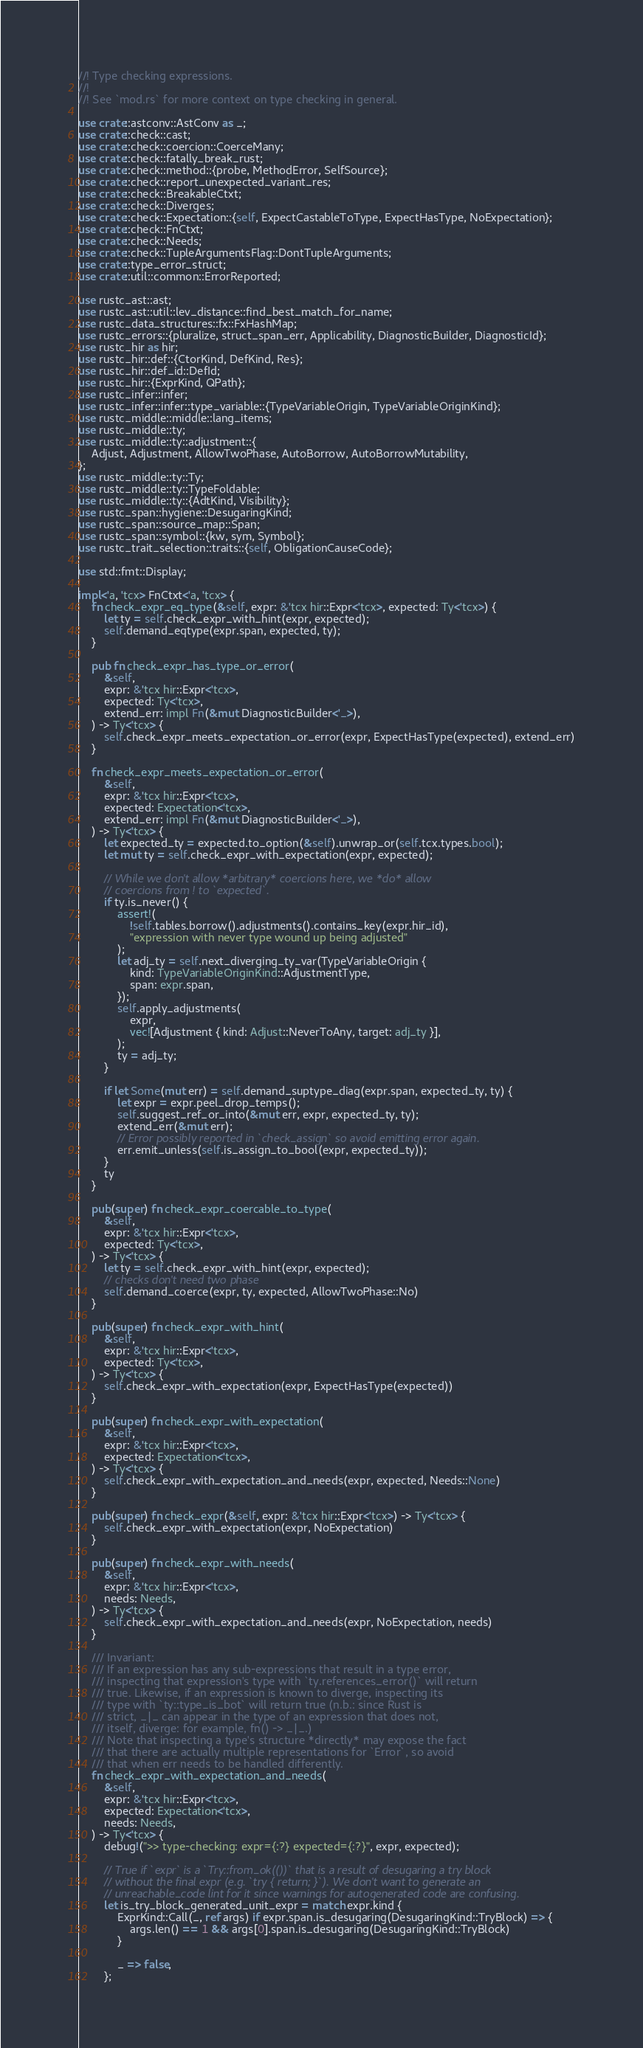Convert code to text. <code><loc_0><loc_0><loc_500><loc_500><_Rust_>//! Type checking expressions.
//!
//! See `mod.rs` for more context on type checking in general.

use crate::astconv::AstConv as _;
use crate::check::cast;
use crate::check::coercion::CoerceMany;
use crate::check::fatally_break_rust;
use crate::check::method::{probe, MethodError, SelfSource};
use crate::check::report_unexpected_variant_res;
use crate::check::BreakableCtxt;
use crate::check::Diverges;
use crate::check::Expectation::{self, ExpectCastableToType, ExpectHasType, NoExpectation};
use crate::check::FnCtxt;
use crate::check::Needs;
use crate::check::TupleArgumentsFlag::DontTupleArguments;
use crate::type_error_struct;
use crate::util::common::ErrorReported;

use rustc_ast::ast;
use rustc_ast::util::lev_distance::find_best_match_for_name;
use rustc_data_structures::fx::FxHashMap;
use rustc_errors::{pluralize, struct_span_err, Applicability, DiagnosticBuilder, DiagnosticId};
use rustc_hir as hir;
use rustc_hir::def::{CtorKind, DefKind, Res};
use rustc_hir::def_id::DefId;
use rustc_hir::{ExprKind, QPath};
use rustc_infer::infer;
use rustc_infer::infer::type_variable::{TypeVariableOrigin, TypeVariableOriginKind};
use rustc_middle::middle::lang_items;
use rustc_middle::ty;
use rustc_middle::ty::adjustment::{
    Adjust, Adjustment, AllowTwoPhase, AutoBorrow, AutoBorrowMutability,
};
use rustc_middle::ty::Ty;
use rustc_middle::ty::TypeFoldable;
use rustc_middle::ty::{AdtKind, Visibility};
use rustc_span::hygiene::DesugaringKind;
use rustc_span::source_map::Span;
use rustc_span::symbol::{kw, sym, Symbol};
use rustc_trait_selection::traits::{self, ObligationCauseCode};

use std::fmt::Display;

impl<'a, 'tcx> FnCtxt<'a, 'tcx> {
    fn check_expr_eq_type(&self, expr: &'tcx hir::Expr<'tcx>, expected: Ty<'tcx>) {
        let ty = self.check_expr_with_hint(expr, expected);
        self.demand_eqtype(expr.span, expected, ty);
    }

    pub fn check_expr_has_type_or_error(
        &self,
        expr: &'tcx hir::Expr<'tcx>,
        expected: Ty<'tcx>,
        extend_err: impl Fn(&mut DiagnosticBuilder<'_>),
    ) -> Ty<'tcx> {
        self.check_expr_meets_expectation_or_error(expr, ExpectHasType(expected), extend_err)
    }

    fn check_expr_meets_expectation_or_error(
        &self,
        expr: &'tcx hir::Expr<'tcx>,
        expected: Expectation<'tcx>,
        extend_err: impl Fn(&mut DiagnosticBuilder<'_>),
    ) -> Ty<'tcx> {
        let expected_ty = expected.to_option(&self).unwrap_or(self.tcx.types.bool);
        let mut ty = self.check_expr_with_expectation(expr, expected);

        // While we don't allow *arbitrary* coercions here, we *do* allow
        // coercions from ! to `expected`.
        if ty.is_never() {
            assert!(
                !self.tables.borrow().adjustments().contains_key(expr.hir_id),
                "expression with never type wound up being adjusted"
            );
            let adj_ty = self.next_diverging_ty_var(TypeVariableOrigin {
                kind: TypeVariableOriginKind::AdjustmentType,
                span: expr.span,
            });
            self.apply_adjustments(
                expr,
                vec![Adjustment { kind: Adjust::NeverToAny, target: adj_ty }],
            );
            ty = adj_ty;
        }

        if let Some(mut err) = self.demand_suptype_diag(expr.span, expected_ty, ty) {
            let expr = expr.peel_drop_temps();
            self.suggest_ref_or_into(&mut err, expr, expected_ty, ty);
            extend_err(&mut err);
            // Error possibly reported in `check_assign` so avoid emitting error again.
            err.emit_unless(self.is_assign_to_bool(expr, expected_ty));
        }
        ty
    }

    pub(super) fn check_expr_coercable_to_type(
        &self,
        expr: &'tcx hir::Expr<'tcx>,
        expected: Ty<'tcx>,
    ) -> Ty<'tcx> {
        let ty = self.check_expr_with_hint(expr, expected);
        // checks don't need two phase
        self.demand_coerce(expr, ty, expected, AllowTwoPhase::No)
    }

    pub(super) fn check_expr_with_hint(
        &self,
        expr: &'tcx hir::Expr<'tcx>,
        expected: Ty<'tcx>,
    ) -> Ty<'tcx> {
        self.check_expr_with_expectation(expr, ExpectHasType(expected))
    }

    pub(super) fn check_expr_with_expectation(
        &self,
        expr: &'tcx hir::Expr<'tcx>,
        expected: Expectation<'tcx>,
    ) -> Ty<'tcx> {
        self.check_expr_with_expectation_and_needs(expr, expected, Needs::None)
    }

    pub(super) fn check_expr(&self, expr: &'tcx hir::Expr<'tcx>) -> Ty<'tcx> {
        self.check_expr_with_expectation(expr, NoExpectation)
    }

    pub(super) fn check_expr_with_needs(
        &self,
        expr: &'tcx hir::Expr<'tcx>,
        needs: Needs,
    ) -> Ty<'tcx> {
        self.check_expr_with_expectation_and_needs(expr, NoExpectation, needs)
    }

    /// Invariant:
    /// If an expression has any sub-expressions that result in a type error,
    /// inspecting that expression's type with `ty.references_error()` will return
    /// true. Likewise, if an expression is known to diverge, inspecting its
    /// type with `ty::type_is_bot` will return true (n.b.: since Rust is
    /// strict, _|_ can appear in the type of an expression that does not,
    /// itself, diverge: for example, fn() -> _|_.)
    /// Note that inspecting a type's structure *directly* may expose the fact
    /// that there are actually multiple representations for `Error`, so avoid
    /// that when err needs to be handled differently.
    fn check_expr_with_expectation_and_needs(
        &self,
        expr: &'tcx hir::Expr<'tcx>,
        expected: Expectation<'tcx>,
        needs: Needs,
    ) -> Ty<'tcx> {
        debug!(">> type-checking: expr={:?} expected={:?}", expr, expected);

        // True if `expr` is a `Try::from_ok(())` that is a result of desugaring a try block
        // without the final expr (e.g. `try { return; }`). We don't want to generate an
        // unreachable_code lint for it since warnings for autogenerated code are confusing.
        let is_try_block_generated_unit_expr = match expr.kind {
            ExprKind::Call(_, ref args) if expr.span.is_desugaring(DesugaringKind::TryBlock) => {
                args.len() == 1 && args[0].span.is_desugaring(DesugaringKind::TryBlock)
            }

            _ => false,
        };
</code> 